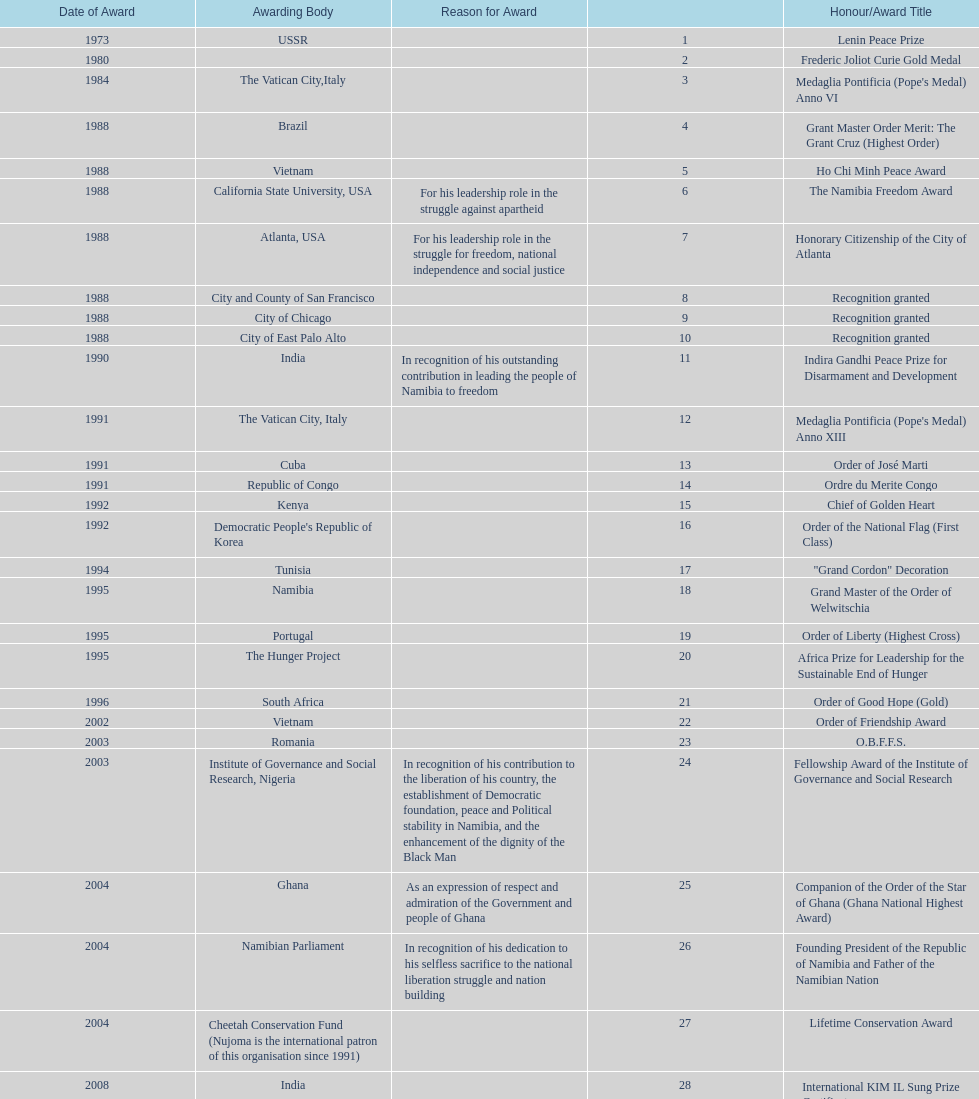Parse the table in full. {'header': ['Date of Award', 'Awarding Body', 'Reason for Award', '', 'Honour/Award Title'], 'rows': [['1973', 'USSR', '', '1', 'Lenin Peace Prize'], ['1980', '', '', '2', 'Frederic Joliot Curie Gold Medal'], ['1984', 'The Vatican City,Italy', '', '3', "Medaglia Pontificia (Pope's Medal) Anno VI"], ['1988', 'Brazil', '', '4', 'Grant Master Order Merit: The Grant Cruz (Highest Order)'], ['1988', 'Vietnam', '', '5', 'Ho Chi Minh Peace Award'], ['1988', 'California State University, USA', 'For his leadership role in the struggle against apartheid', '6', 'The Namibia Freedom Award'], ['1988', 'Atlanta, USA', 'For his leadership role in the struggle for freedom, national independence and social justice', '7', 'Honorary Citizenship of the City of Atlanta'], ['1988', 'City and County of San Francisco', '', '8', 'Recognition granted'], ['1988', 'City of Chicago', '', '9', 'Recognition granted'], ['1988', 'City of East Palo Alto', '', '10', 'Recognition granted'], ['1990', 'India', 'In recognition of his outstanding contribution in leading the people of Namibia to freedom', '11', 'Indira Gandhi Peace Prize for Disarmament and Development'], ['1991', 'The Vatican City, Italy', '', '12', "Medaglia Pontificia (Pope's Medal) Anno XIII"], ['1991', 'Cuba', '', '13', 'Order of José Marti'], ['1991', 'Republic of Congo', '', '14', 'Ordre du Merite Congo'], ['1992', 'Kenya', '', '15', 'Chief of Golden Heart'], ['1992', "Democratic People's Republic of Korea", '', '16', 'Order of the National Flag (First Class)'], ['1994', 'Tunisia', '', '17', '"Grand Cordon" Decoration'], ['1995', 'Namibia', '', '18', 'Grand Master of the Order of Welwitschia'], ['1995', 'Portugal', '', '19', 'Order of Liberty (Highest Cross)'], ['1995', 'The Hunger Project', '', '20', 'Africa Prize for Leadership for the Sustainable End of Hunger'], ['1996', 'South Africa', '', '21', 'Order of Good Hope (Gold)'], ['2002', 'Vietnam', '', '22', 'Order of Friendship Award'], ['2003', 'Romania', '', '23', 'O.B.F.F.S.'], ['2003', 'Institute of Governance and Social Research, Nigeria', 'In recognition of his contribution to the liberation of his country, the establishment of Democratic foundation, peace and Political stability in Namibia, and the enhancement of the dignity of the Black Man', '24', 'Fellowship Award of the Institute of Governance and Social Research'], ['2004', 'Ghana', 'As an expression of respect and admiration of the Government and people of Ghana', '25', 'Companion of the Order of the Star of Ghana (Ghana National Highest Award)'], ['2004', 'Namibian Parliament', 'In recognition of his dedication to his selfless sacrifice to the national liberation struggle and nation building', '26', 'Founding President of the Republic of Namibia and Father of the Namibian Nation'], ['2004', 'Cheetah Conservation Fund (Nujoma is the international patron of this organisation since 1991)', '', '27', 'Lifetime Conservation Award'], ['2008', 'India', '', '28', 'International KIM IL Sung Prize Certificate'], ['2010', 'SADC', '', '29', 'Sir Seretse Khama SADC Meda']]} What were the total number of honors/award titles listed according to this chart? 29. 